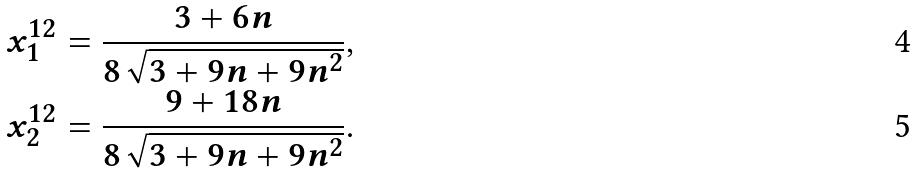<formula> <loc_0><loc_0><loc_500><loc_500>x ^ { 1 2 } _ { 1 } & = \frac { 3 + 6 n } { 8 \sqrt { 3 + 9 n + 9 n ^ { 2 } } } , \\ x ^ { 1 2 } _ { 2 } & = \frac { 9 + 1 8 n } { 8 \sqrt { 3 + 9 n + 9 n ^ { 2 } } } .</formula> 